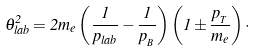<formula> <loc_0><loc_0><loc_500><loc_500>\theta ^ { 2 } _ { l a b } = 2 m _ { e } \left ( \frac { 1 } { p _ { l a b } } - \frac { 1 } { p _ { _ { B } } } \right ) \left ( 1 \pm \frac { p _ { _ { T } } } { m _ { e } } \right ) \cdot</formula> 